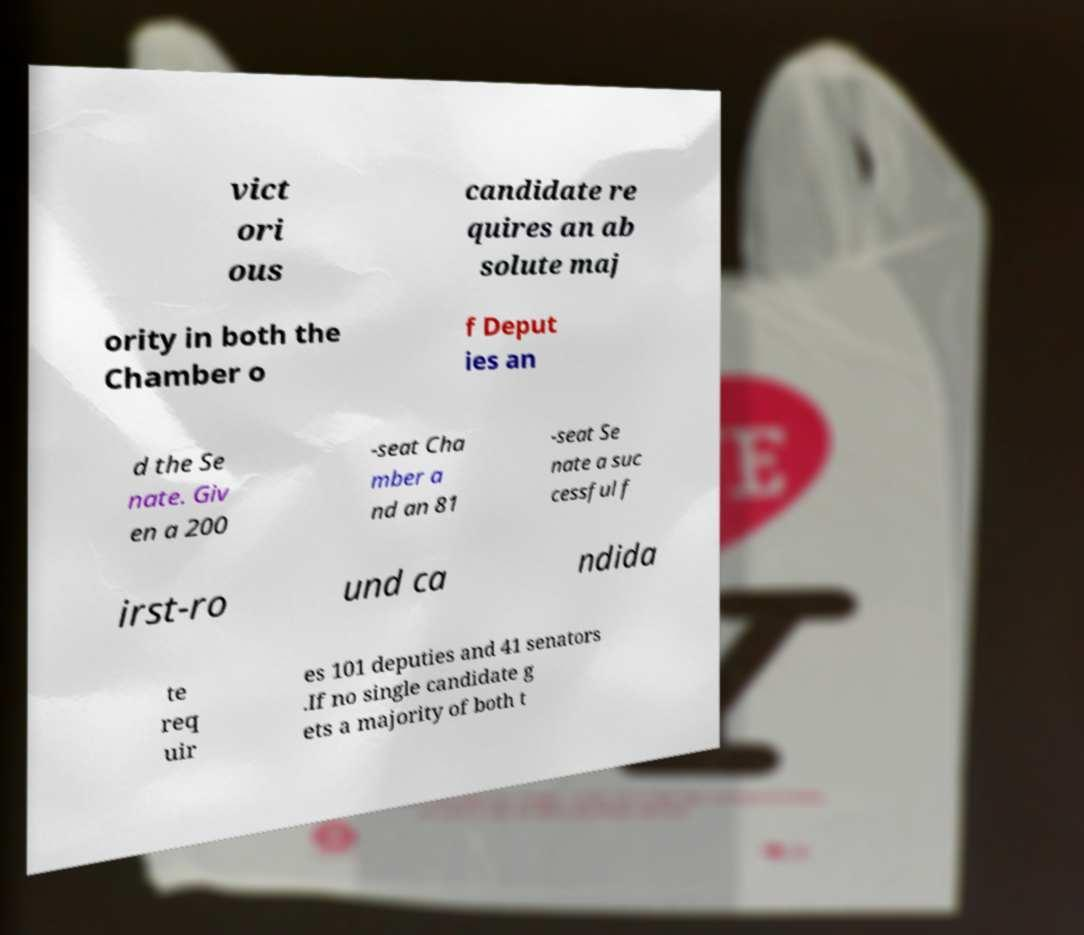What messages or text are displayed in this image? I need them in a readable, typed format. vict ori ous candidate re quires an ab solute maj ority in both the Chamber o f Deput ies an d the Se nate. Giv en a 200 -seat Cha mber a nd an 81 -seat Se nate a suc cessful f irst-ro und ca ndida te req uir es 101 deputies and 41 senators .If no single candidate g ets a majority of both t 